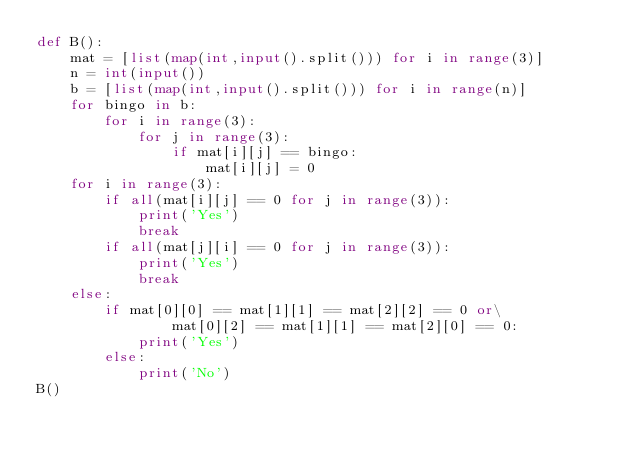Convert code to text. <code><loc_0><loc_0><loc_500><loc_500><_Python_>def B():
    mat = [list(map(int,input().split())) for i in range(3)]
    n = int(input())
    b = [list(map(int,input().split())) for i in range(n)]
    for bingo in b:
        for i in range(3):
            for j in range(3):
                if mat[i][j] == bingo:
                    mat[i][j] = 0
    for i in range(3):
        if all(mat[i][j] == 0 for j in range(3)):
            print('Yes')
            break
        if all(mat[j][i] == 0 for j in range(3)):
            print('Yes')
            break
    else:
        if mat[0][0] == mat[1][1] == mat[2][2] == 0 or\
                mat[0][2] == mat[1][1] == mat[2][0] == 0:
            print('Yes')
        else:
            print('No')
B()</code> 